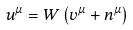<formula> <loc_0><loc_0><loc_500><loc_500>u ^ { \mu } = W \left ( v ^ { \mu } + n ^ { \mu } \right )</formula> 